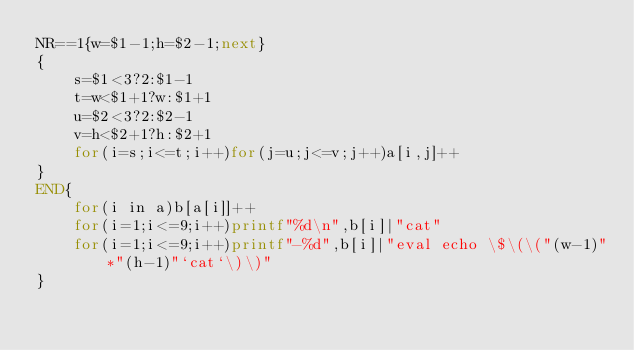Convert code to text. <code><loc_0><loc_0><loc_500><loc_500><_Awk_>NR==1{w=$1-1;h=$2-1;next}
{
	s=$1<3?2:$1-1
	t=w<$1+1?w:$1+1
	u=$2<3?2:$2-1
	v=h<$2+1?h:$2+1
	for(i=s;i<=t;i++)for(j=u;j<=v;j++)a[i,j]++
}
END{
	for(i in a)b[a[i]]++
	for(i=1;i<=9;i++)printf"%d\n",b[i]|"cat"
	for(i=1;i<=9;i++)printf"-%d",b[i]|"eval echo \$\(\("(w-1)"*"(h-1)"`cat`\)\)"
}</code> 